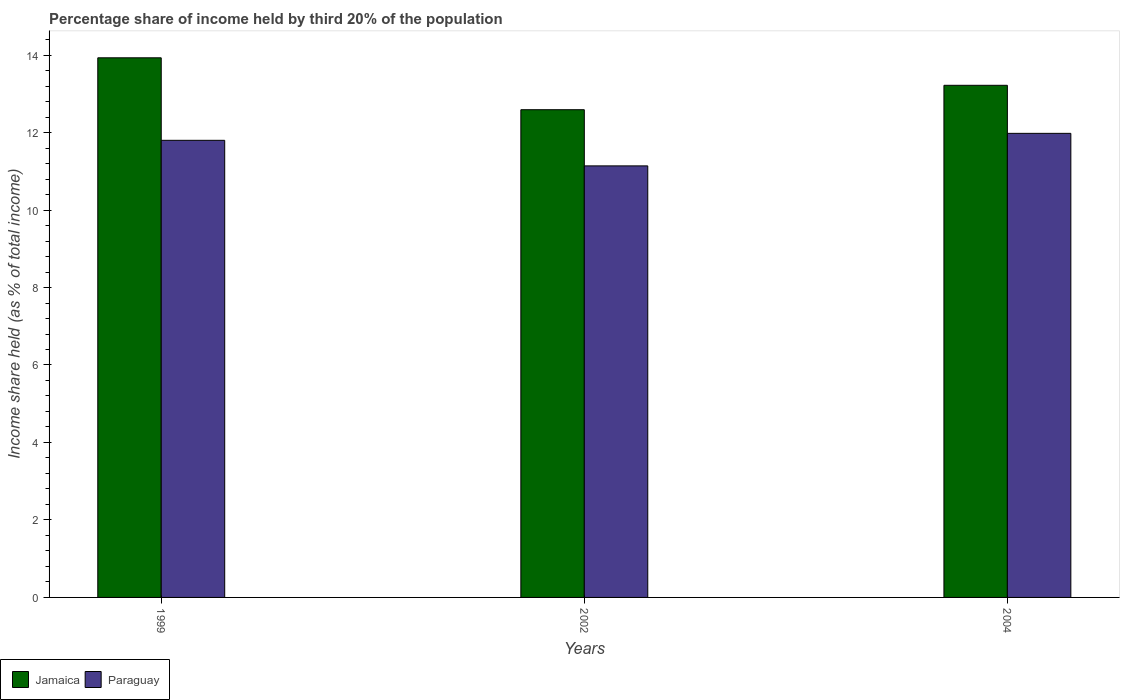How many different coloured bars are there?
Your answer should be very brief. 2. Are the number of bars per tick equal to the number of legend labels?
Provide a short and direct response. Yes. Are the number of bars on each tick of the X-axis equal?
Your response must be concise. Yes. How many bars are there on the 2nd tick from the left?
Give a very brief answer. 2. In how many cases, is the number of bars for a given year not equal to the number of legend labels?
Offer a terse response. 0. What is the share of income held by third 20% of the population in Jamaica in 2004?
Your response must be concise. 13.22. Across all years, what is the maximum share of income held by third 20% of the population in Jamaica?
Your answer should be compact. 13.93. Across all years, what is the minimum share of income held by third 20% of the population in Paraguay?
Your answer should be compact. 11.14. In which year was the share of income held by third 20% of the population in Jamaica maximum?
Your answer should be very brief. 1999. What is the total share of income held by third 20% of the population in Paraguay in the graph?
Offer a very short reply. 34.92. What is the difference between the share of income held by third 20% of the population in Jamaica in 2002 and that in 2004?
Your response must be concise. -0.63. What is the difference between the share of income held by third 20% of the population in Jamaica in 2002 and the share of income held by third 20% of the population in Paraguay in 1999?
Provide a short and direct response. 0.79. What is the average share of income held by third 20% of the population in Paraguay per year?
Your answer should be very brief. 11.64. In the year 2004, what is the difference between the share of income held by third 20% of the population in Jamaica and share of income held by third 20% of the population in Paraguay?
Offer a terse response. 1.24. In how many years, is the share of income held by third 20% of the population in Jamaica greater than 10 %?
Offer a terse response. 3. What is the ratio of the share of income held by third 20% of the population in Paraguay in 2002 to that in 2004?
Your response must be concise. 0.93. Is the share of income held by third 20% of the population in Paraguay in 2002 less than that in 2004?
Your answer should be very brief. Yes. Is the difference between the share of income held by third 20% of the population in Jamaica in 1999 and 2002 greater than the difference between the share of income held by third 20% of the population in Paraguay in 1999 and 2002?
Offer a terse response. Yes. What is the difference between the highest and the second highest share of income held by third 20% of the population in Paraguay?
Your response must be concise. 0.18. What is the difference between the highest and the lowest share of income held by third 20% of the population in Jamaica?
Provide a succinct answer. 1.34. In how many years, is the share of income held by third 20% of the population in Paraguay greater than the average share of income held by third 20% of the population in Paraguay taken over all years?
Offer a very short reply. 2. Is the sum of the share of income held by third 20% of the population in Jamaica in 2002 and 2004 greater than the maximum share of income held by third 20% of the population in Paraguay across all years?
Your answer should be compact. Yes. What does the 1st bar from the left in 2004 represents?
Keep it short and to the point. Jamaica. What does the 2nd bar from the right in 1999 represents?
Offer a terse response. Jamaica. How many years are there in the graph?
Ensure brevity in your answer.  3. What is the difference between two consecutive major ticks on the Y-axis?
Ensure brevity in your answer.  2. Does the graph contain any zero values?
Ensure brevity in your answer.  No. How many legend labels are there?
Offer a terse response. 2. What is the title of the graph?
Your response must be concise. Percentage share of income held by third 20% of the population. What is the label or title of the X-axis?
Make the answer very short. Years. What is the label or title of the Y-axis?
Provide a succinct answer. Income share held (as % of total income). What is the Income share held (as % of total income) of Jamaica in 1999?
Your response must be concise. 13.93. What is the Income share held (as % of total income) of Paraguay in 1999?
Offer a very short reply. 11.8. What is the Income share held (as % of total income) of Jamaica in 2002?
Your response must be concise. 12.59. What is the Income share held (as % of total income) of Paraguay in 2002?
Keep it short and to the point. 11.14. What is the Income share held (as % of total income) in Jamaica in 2004?
Your answer should be compact. 13.22. What is the Income share held (as % of total income) in Paraguay in 2004?
Provide a succinct answer. 11.98. Across all years, what is the maximum Income share held (as % of total income) of Jamaica?
Ensure brevity in your answer.  13.93. Across all years, what is the maximum Income share held (as % of total income) of Paraguay?
Ensure brevity in your answer.  11.98. Across all years, what is the minimum Income share held (as % of total income) in Jamaica?
Offer a very short reply. 12.59. Across all years, what is the minimum Income share held (as % of total income) of Paraguay?
Offer a terse response. 11.14. What is the total Income share held (as % of total income) of Jamaica in the graph?
Your answer should be very brief. 39.74. What is the total Income share held (as % of total income) in Paraguay in the graph?
Provide a short and direct response. 34.92. What is the difference between the Income share held (as % of total income) in Jamaica in 1999 and that in 2002?
Provide a short and direct response. 1.34. What is the difference between the Income share held (as % of total income) of Paraguay in 1999 and that in 2002?
Offer a terse response. 0.66. What is the difference between the Income share held (as % of total income) of Jamaica in 1999 and that in 2004?
Offer a terse response. 0.71. What is the difference between the Income share held (as % of total income) in Paraguay in 1999 and that in 2004?
Make the answer very short. -0.18. What is the difference between the Income share held (as % of total income) in Jamaica in 2002 and that in 2004?
Give a very brief answer. -0.63. What is the difference between the Income share held (as % of total income) in Paraguay in 2002 and that in 2004?
Keep it short and to the point. -0.84. What is the difference between the Income share held (as % of total income) in Jamaica in 1999 and the Income share held (as % of total income) in Paraguay in 2002?
Your answer should be very brief. 2.79. What is the difference between the Income share held (as % of total income) of Jamaica in 1999 and the Income share held (as % of total income) of Paraguay in 2004?
Your response must be concise. 1.95. What is the difference between the Income share held (as % of total income) in Jamaica in 2002 and the Income share held (as % of total income) in Paraguay in 2004?
Offer a very short reply. 0.61. What is the average Income share held (as % of total income) of Jamaica per year?
Make the answer very short. 13.25. What is the average Income share held (as % of total income) in Paraguay per year?
Offer a very short reply. 11.64. In the year 1999, what is the difference between the Income share held (as % of total income) of Jamaica and Income share held (as % of total income) of Paraguay?
Give a very brief answer. 2.13. In the year 2002, what is the difference between the Income share held (as % of total income) of Jamaica and Income share held (as % of total income) of Paraguay?
Your answer should be very brief. 1.45. In the year 2004, what is the difference between the Income share held (as % of total income) in Jamaica and Income share held (as % of total income) in Paraguay?
Ensure brevity in your answer.  1.24. What is the ratio of the Income share held (as % of total income) of Jamaica in 1999 to that in 2002?
Keep it short and to the point. 1.11. What is the ratio of the Income share held (as % of total income) in Paraguay in 1999 to that in 2002?
Your answer should be compact. 1.06. What is the ratio of the Income share held (as % of total income) in Jamaica in 1999 to that in 2004?
Offer a very short reply. 1.05. What is the ratio of the Income share held (as % of total income) in Paraguay in 1999 to that in 2004?
Your answer should be compact. 0.98. What is the ratio of the Income share held (as % of total income) in Jamaica in 2002 to that in 2004?
Provide a succinct answer. 0.95. What is the ratio of the Income share held (as % of total income) of Paraguay in 2002 to that in 2004?
Ensure brevity in your answer.  0.93. What is the difference between the highest and the second highest Income share held (as % of total income) in Jamaica?
Provide a succinct answer. 0.71. What is the difference between the highest and the second highest Income share held (as % of total income) of Paraguay?
Provide a succinct answer. 0.18. What is the difference between the highest and the lowest Income share held (as % of total income) of Jamaica?
Offer a terse response. 1.34. What is the difference between the highest and the lowest Income share held (as % of total income) of Paraguay?
Make the answer very short. 0.84. 